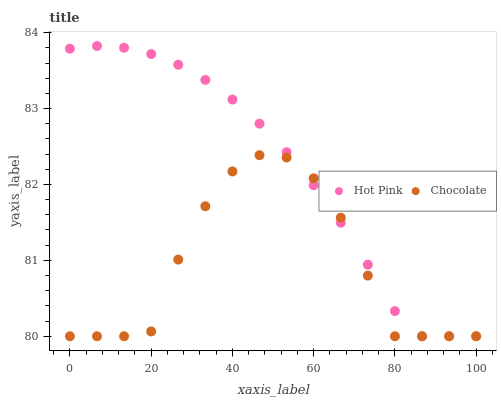Does Chocolate have the minimum area under the curve?
Answer yes or no. Yes. Does Hot Pink have the maximum area under the curve?
Answer yes or no. Yes. Does Chocolate have the maximum area under the curve?
Answer yes or no. No. Is Hot Pink the smoothest?
Answer yes or no. Yes. Is Chocolate the roughest?
Answer yes or no. Yes. Is Chocolate the smoothest?
Answer yes or no. No. Does Hot Pink have the lowest value?
Answer yes or no. Yes. Does Hot Pink have the highest value?
Answer yes or no. Yes. Does Chocolate have the highest value?
Answer yes or no. No. Does Hot Pink intersect Chocolate?
Answer yes or no. Yes. Is Hot Pink less than Chocolate?
Answer yes or no. No. Is Hot Pink greater than Chocolate?
Answer yes or no. No. 